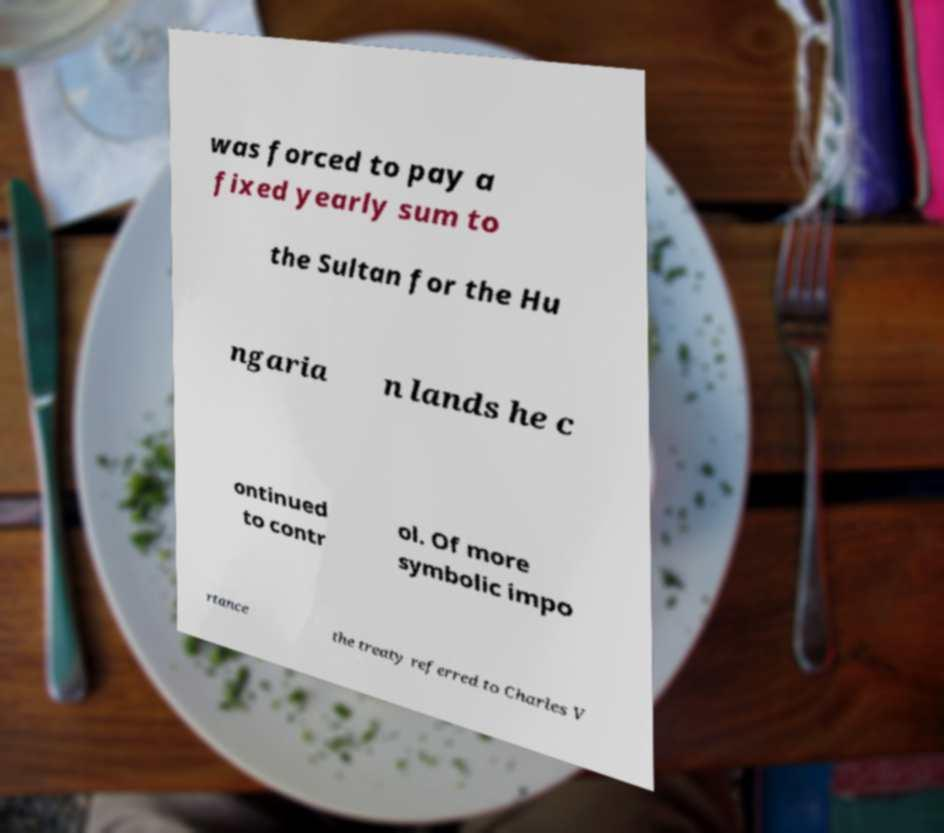Can you accurately transcribe the text from the provided image for me? was forced to pay a fixed yearly sum to the Sultan for the Hu ngaria n lands he c ontinued to contr ol. Of more symbolic impo rtance the treaty referred to Charles V 